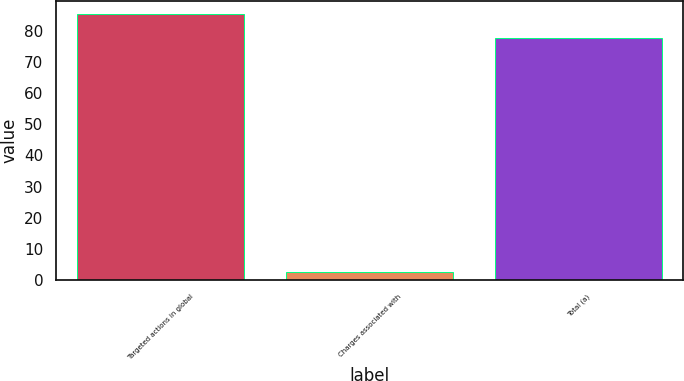<chart> <loc_0><loc_0><loc_500><loc_500><bar_chart><fcel>Targeted actions in global<fcel>Charges associated with<fcel>Total (a)<nl><fcel>85.36<fcel>2.6<fcel>77.6<nl></chart> 